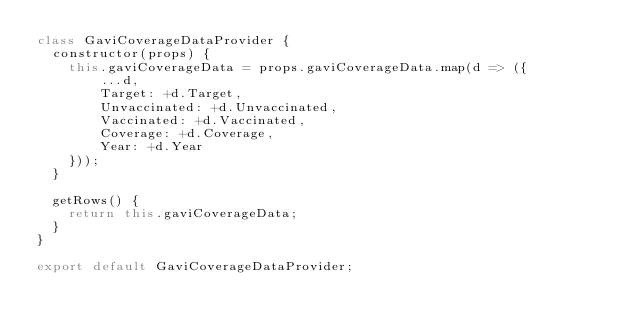Convert code to text. <code><loc_0><loc_0><loc_500><loc_500><_JavaScript_>class GaviCoverageDataProvider {
  constructor(props) {
    this.gaviCoverageData = props.gaviCoverageData.map(d => ({
        ...d,
        Target: +d.Target,
        Unvaccinated: +d.Unvaccinated,
        Vaccinated: +d.Vaccinated,
        Coverage: +d.Coverage,
        Year: +d.Year
    }));
  }

  getRows() {
    return this.gaviCoverageData;
  }
}

export default GaviCoverageDataProvider;
</code> 